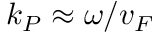Convert formula to latex. <formula><loc_0><loc_0><loc_500><loc_500>k _ { P } \approx \omega / v _ { F }</formula> 